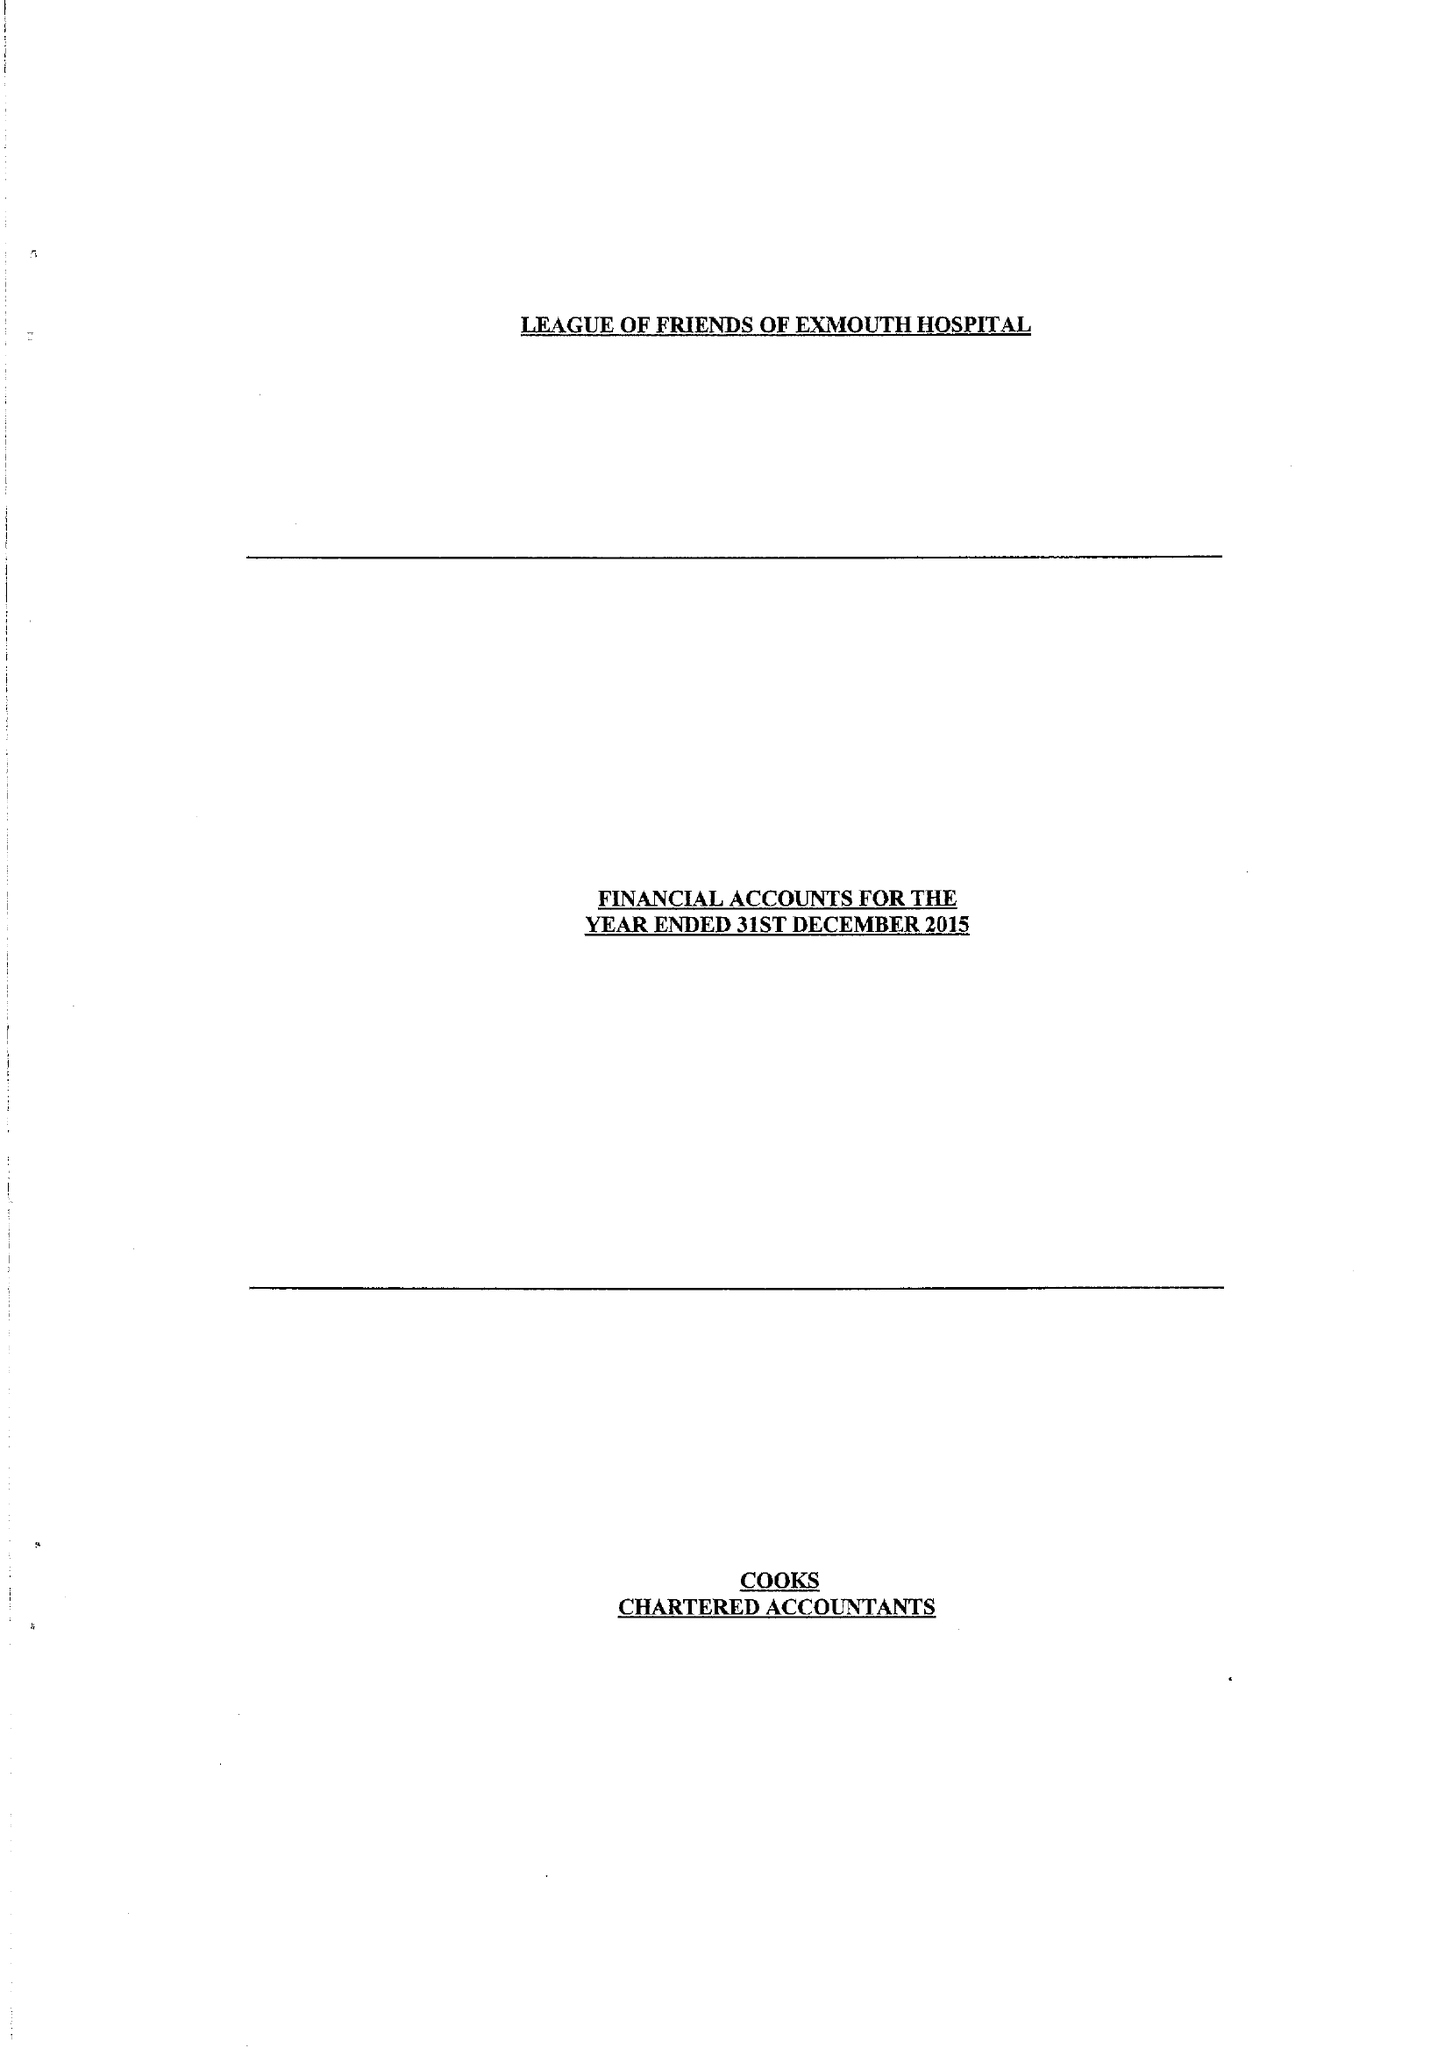What is the value for the income_annually_in_british_pounds?
Answer the question using a single word or phrase. 29450.00 